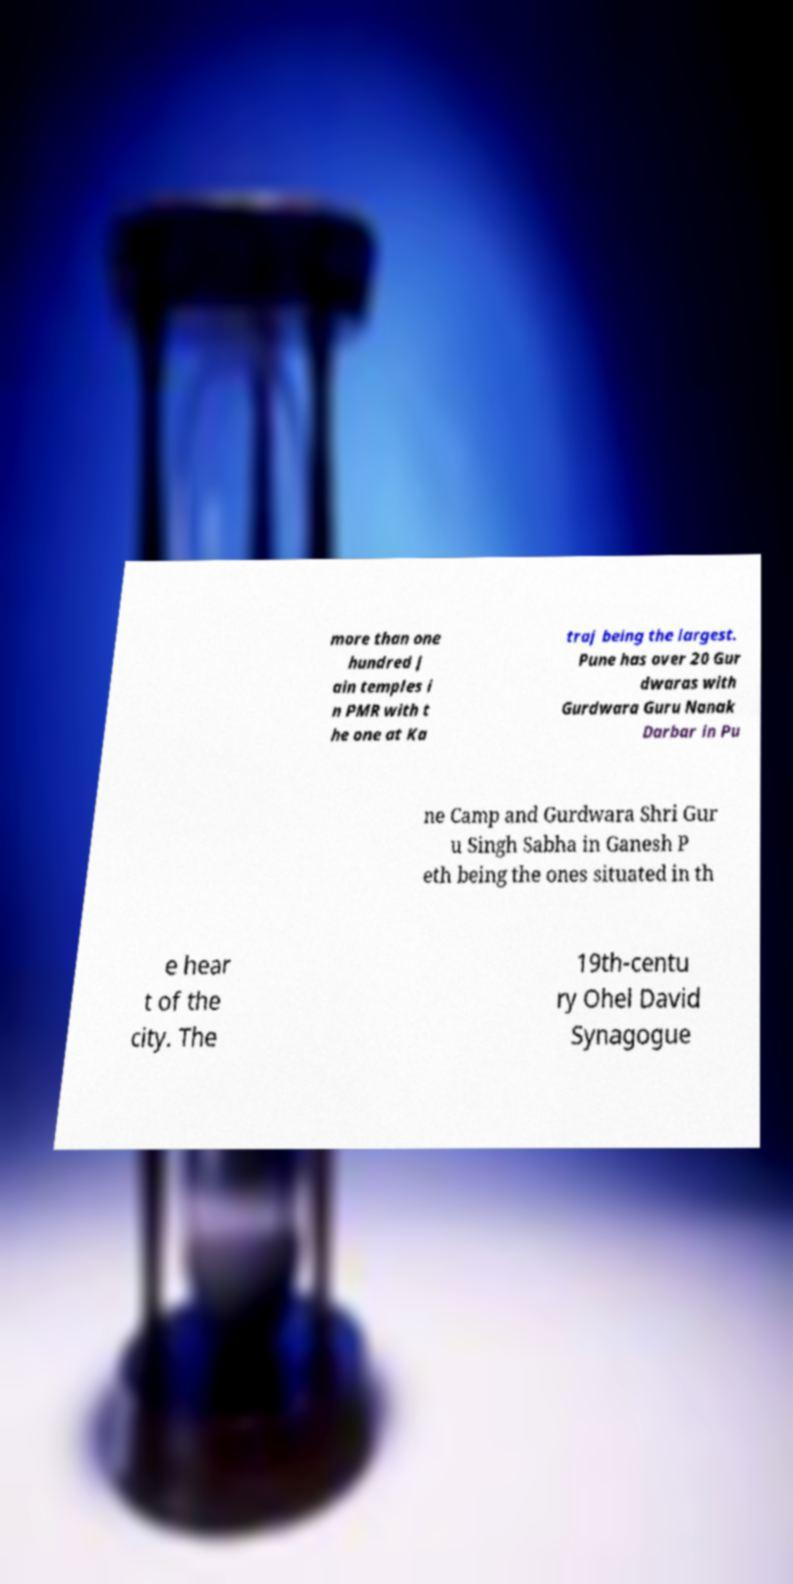Can you accurately transcribe the text from the provided image for me? more than one hundred J ain temples i n PMR with t he one at Ka traj being the largest. Pune has over 20 Gur dwaras with Gurdwara Guru Nanak Darbar in Pu ne Camp and Gurdwara Shri Gur u Singh Sabha in Ganesh P eth being the ones situated in th e hear t of the city. The 19th-centu ry Ohel David Synagogue 